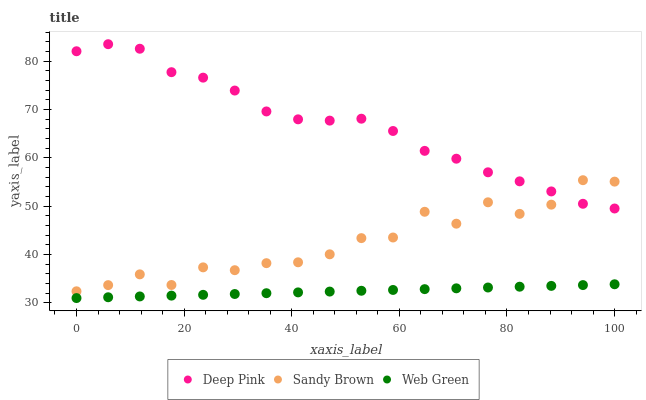Does Web Green have the minimum area under the curve?
Answer yes or no. Yes. Does Deep Pink have the maximum area under the curve?
Answer yes or no. Yes. Does Sandy Brown have the minimum area under the curve?
Answer yes or no. No. Does Sandy Brown have the maximum area under the curve?
Answer yes or no. No. Is Web Green the smoothest?
Answer yes or no. Yes. Is Sandy Brown the roughest?
Answer yes or no. Yes. Is Sandy Brown the smoothest?
Answer yes or no. No. Is Web Green the roughest?
Answer yes or no. No. Does Web Green have the lowest value?
Answer yes or no. Yes. Does Sandy Brown have the lowest value?
Answer yes or no. No. Does Deep Pink have the highest value?
Answer yes or no. Yes. Does Sandy Brown have the highest value?
Answer yes or no. No. Is Web Green less than Sandy Brown?
Answer yes or no. Yes. Is Sandy Brown greater than Web Green?
Answer yes or no. Yes. Does Deep Pink intersect Sandy Brown?
Answer yes or no. Yes. Is Deep Pink less than Sandy Brown?
Answer yes or no. No. Is Deep Pink greater than Sandy Brown?
Answer yes or no. No. Does Web Green intersect Sandy Brown?
Answer yes or no. No. 